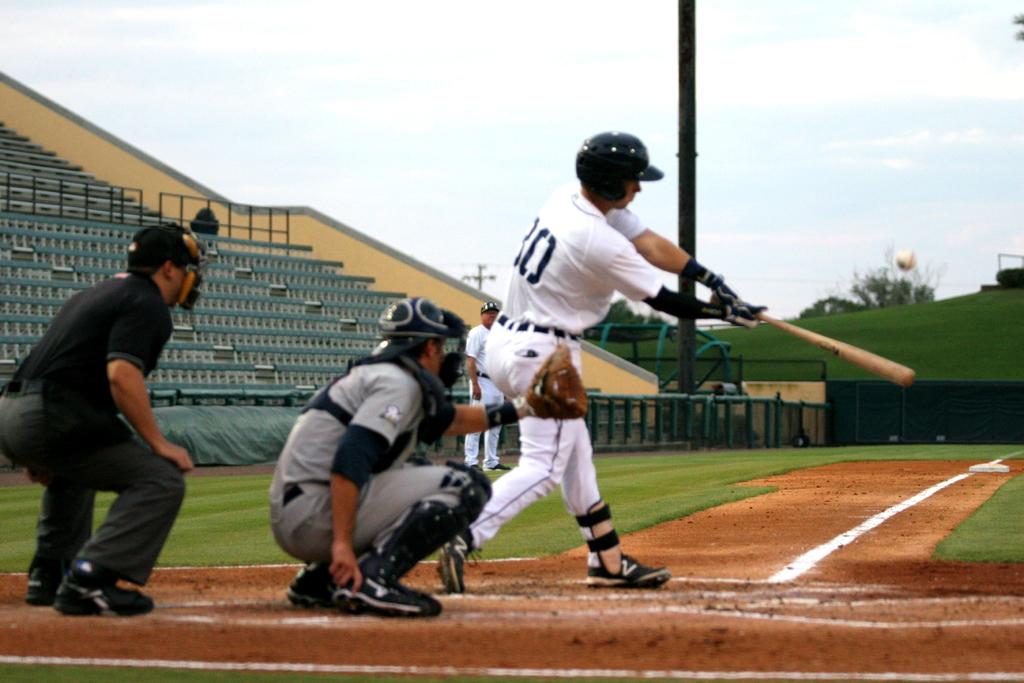What jersey number is seen on the batter?
Your response must be concise. 30. 